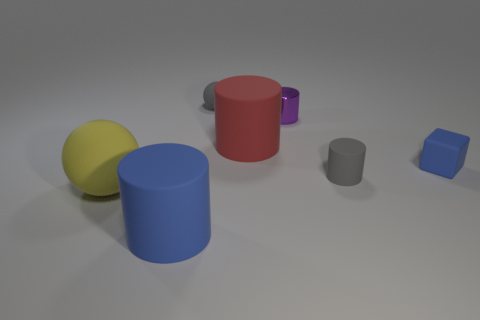What size is the block that is the same material as the yellow object?
Your response must be concise. Small. How many objects are both in front of the large red thing and on the left side of the small matte cube?
Your response must be concise. 3. What number of objects are tiny matte cylinders or gray things that are to the left of the small matte cylinder?
Offer a very short reply. 2. There is a object that is the same color as the tiny rubber cylinder; what shape is it?
Your response must be concise. Sphere. What color is the large rubber cylinder that is right of the blue cylinder?
Provide a short and direct response. Red. What number of objects are either large cylinders that are behind the blue matte cube or small blue objects?
Your answer should be very brief. 2. There is a ball that is the same size as the block; what is its color?
Make the answer very short. Gray. Are there more large objects to the right of the red rubber object than small matte cylinders?
Offer a very short reply. No. What is the large thing that is to the right of the big yellow matte ball and in front of the blue matte block made of?
Give a very brief answer. Rubber. Is the color of the small object to the left of the tiny purple cylinder the same as the sphere in front of the small blue block?
Your response must be concise. No. 